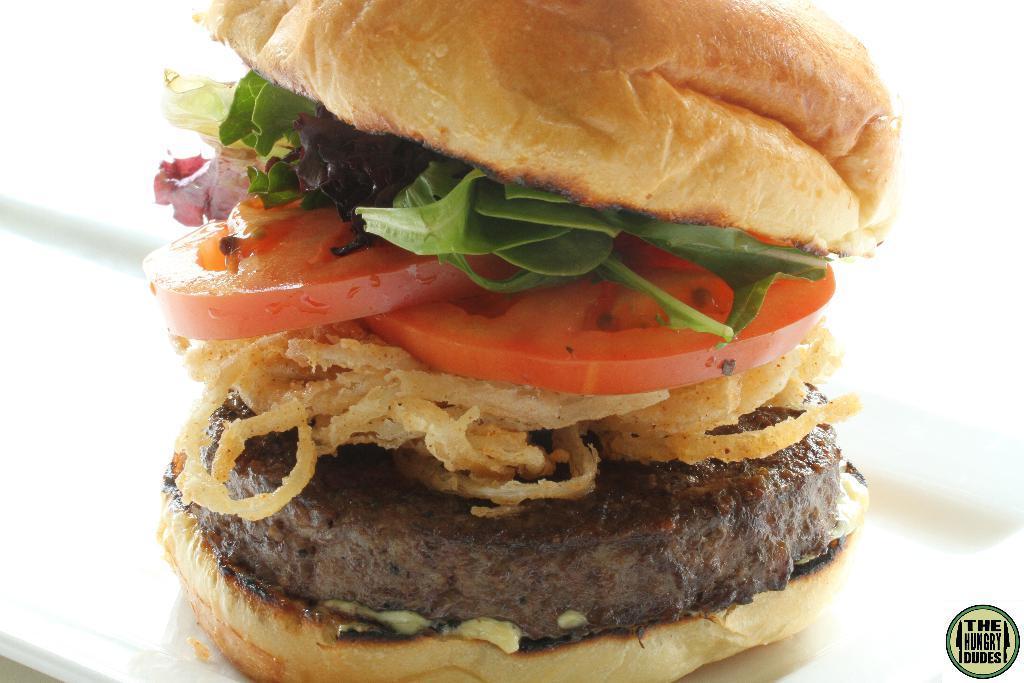Describe this image in one or two sentences. There is a burger which has tomato slices, onion rings, meat and other ingredients. The background is white. 